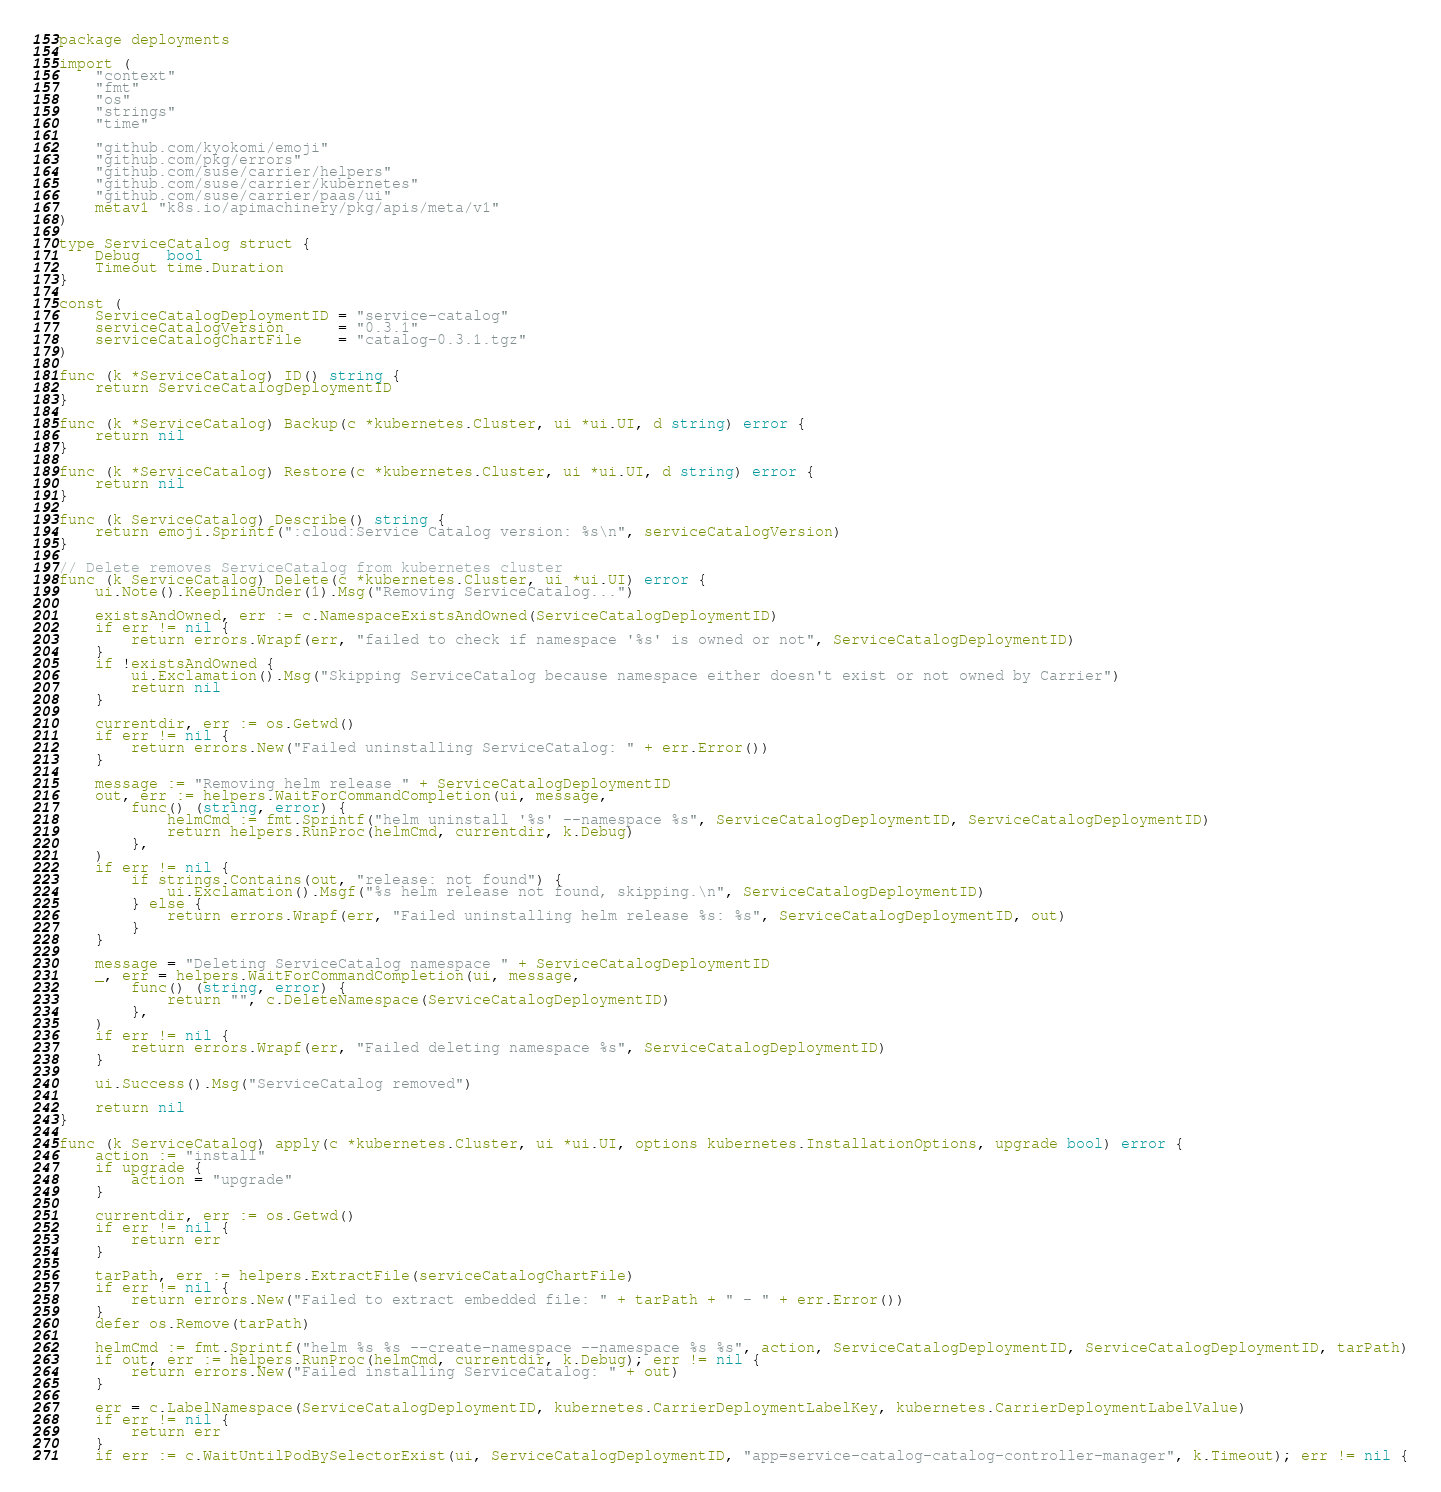<code> <loc_0><loc_0><loc_500><loc_500><_Go_>package deployments

import (
	"context"
	"fmt"
	"os"
	"strings"
	"time"

	"github.com/kyokomi/emoji"
	"github.com/pkg/errors"
	"github.com/suse/carrier/helpers"
	"github.com/suse/carrier/kubernetes"
	"github.com/suse/carrier/paas/ui"
	metav1 "k8s.io/apimachinery/pkg/apis/meta/v1"
)

type ServiceCatalog struct {
	Debug   bool
	Timeout time.Duration
}

const (
	ServiceCatalogDeploymentID = "service-catalog"
	serviceCatalogVersion      = "0.3.1"
	serviceCatalogChartFile    = "catalog-0.3.1.tgz"
)

func (k *ServiceCatalog) ID() string {
	return ServiceCatalogDeploymentID
}

func (k *ServiceCatalog) Backup(c *kubernetes.Cluster, ui *ui.UI, d string) error {
	return nil
}

func (k *ServiceCatalog) Restore(c *kubernetes.Cluster, ui *ui.UI, d string) error {
	return nil
}

func (k ServiceCatalog) Describe() string {
	return emoji.Sprintf(":cloud:Service Catalog version: %s\n", serviceCatalogVersion)
}

// Delete removes ServiceCatalog from kubernetes cluster
func (k ServiceCatalog) Delete(c *kubernetes.Cluster, ui *ui.UI) error {
	ui.Note().KeeplineUnder(1).Msg("Removing ServiceCatalog...")

	existsAndOwned, err := c.NamespaceExistsAndOwned(ServiceCatalogDeploymentID)
	if err != nil {
		return errors.Wrapf(err, "failed to check if namespace '%s' is owned or not", ServiceCatalogDeploymentID)
	}
	if !existsAndOwned {
		ui.Exclamation().Msg("Skipping ServiceCatalog because namespace either doesn't exist or not owned by Carrier")
		return nil
	}

	currentdir, err := os.Getwd()
	if err != nil {
		return errors.New("Failed uninstalling ServiceCatalog: " + err.Error())
	}

	message := "Removing helm release " + ServiceCatalogDeploymentID
	out, err := helpers.WaitForCommandCompletion(ui, message,
		func() (string, error) {
			helmCmd := fmt.Sprintf("helm uninstall '%s' --namespace %s", ServiceCatalogDeploymentID, ServiceCatalogDeploymentID)
			return helpers.RunProc(helmCmd, currentdir, k.Debug)
		},
	)
	if err != nil {
		if strings.Contains(out, "release: not found") {
			ui.Exclamation().Msgf("%s helm release not found, skipping.\n", ServiceCatalogDeploymentID)
		} else {
			return errors.Wrapf(err, "Failed uninstalling helm release %s: %s", ServiceCatalogDeploymentID, out)
		}
	}

	message = "Deleting ServiceCatalog namespace " + ServiceCatalogDeploymentID
	_, err = helpers.WaitForCommandCompletion(ui, message,
		func() (string, error) {
			return "", c.DeleteNamespace(ServiceCatalogDeploymentID)
		},
	)
	if err != nil {
		return errors.Wrapf(err, "Failed deleting namespace %s", ServiceCatalogDeploymentID)
	}

	ui.Success().Msg("ServiceCatalog removed")

	return nil
}

func (k ServiceCatalog) apply(c *kubernetes.Cluster, ui *ui.UI, options kubernetes.InstallationOptions, upgrade bool) error {
	action := "install"
	if upgrade {
		action = "upgrade"
	}

	currentdir, err := os.Getwd()
	if err != nil {
		return err
	}

	tarPath, err := helpers.ExtractFile(serviceCatalogChartFile)
	if err != nil {
		return errors.New("Failed to extract embedded file: " + tarPath + " - " + err.Error())
	}
	defer os.Remove(tarPath)

	helmCmd := fmt.Sprintf("helm %s %s --create-namespace --namespace %s %s", action, ServiceCatalogDeploymentID, ServiceCatalogDeploymentID, tarPath)
	if out, err := helpers.RunProc(helmCmd, currentdir, k.Debug); err != nil {
		return errors.New("Failed installing ServiceCatalog: " + out)
	}

	err = c.LabelNamespace(ServiceCatalogDeploymentID, kubernetes.CarrierDeploymentLabelKey, kubernetes.CarrierDeploymentLabelValue)
	if err != nil {
		return err
	}
	if err := c.WaitUntilPodBySelectorExist(ui, ServiceCatalogDeploymentID, "app=service-catalog-catalog-controller-manager", k.Timeout); err != nil {</code> 